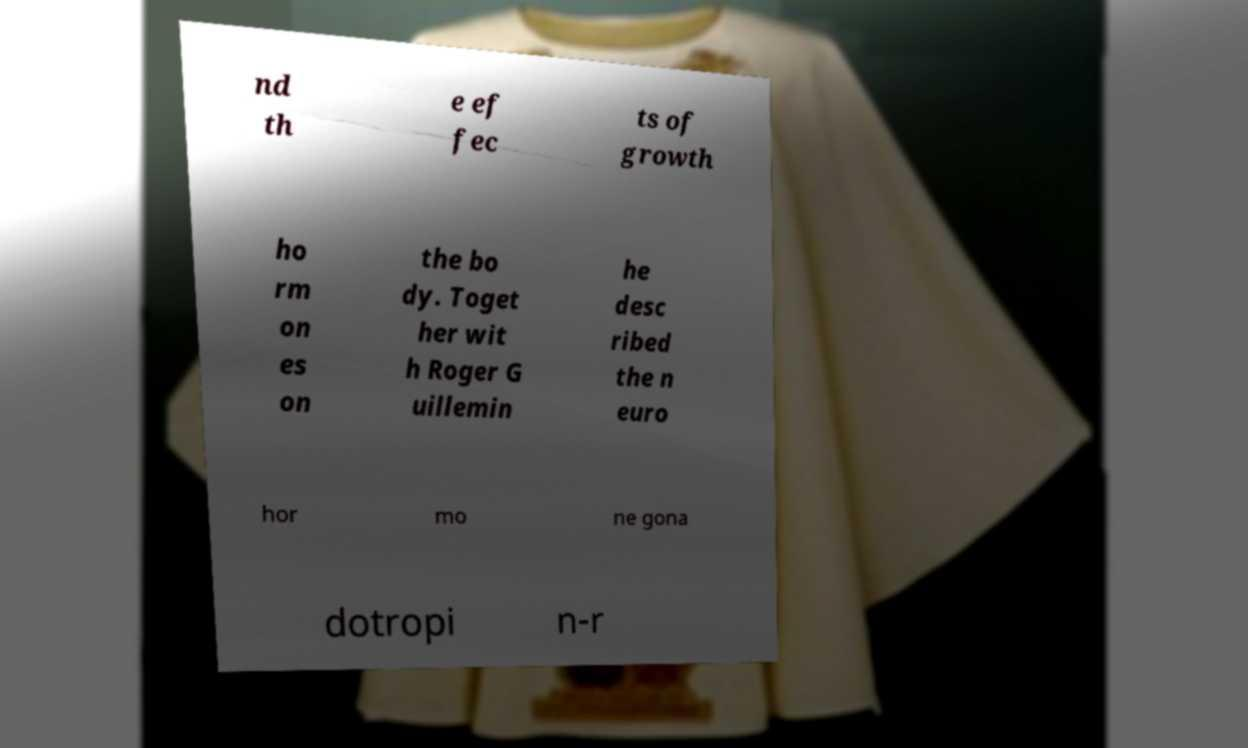Could you assist in decoding the text presented in this image and type it out clearly? nd th e ef fec ts of growth ho rm on es on the bo dy. Toget her wit h Roger G uillemin he desc ribed the n euro hor mo ne gona dotropi n-r 